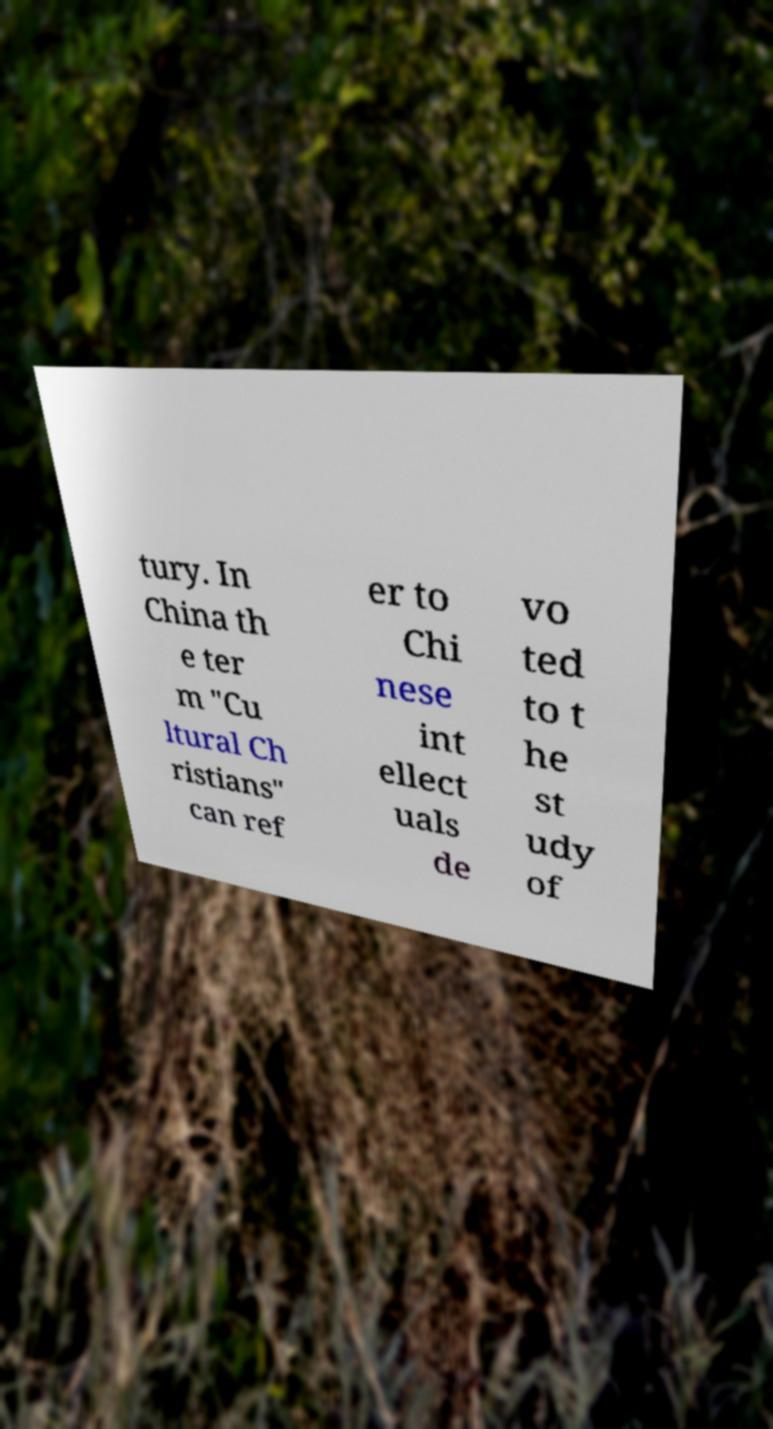Please identify and transcribe the text found in this image. tury. In China th e ter m "Cu ltural Ch ristians" can ref er to Chi nese int ellect uals de vo ted to t he st udy of 